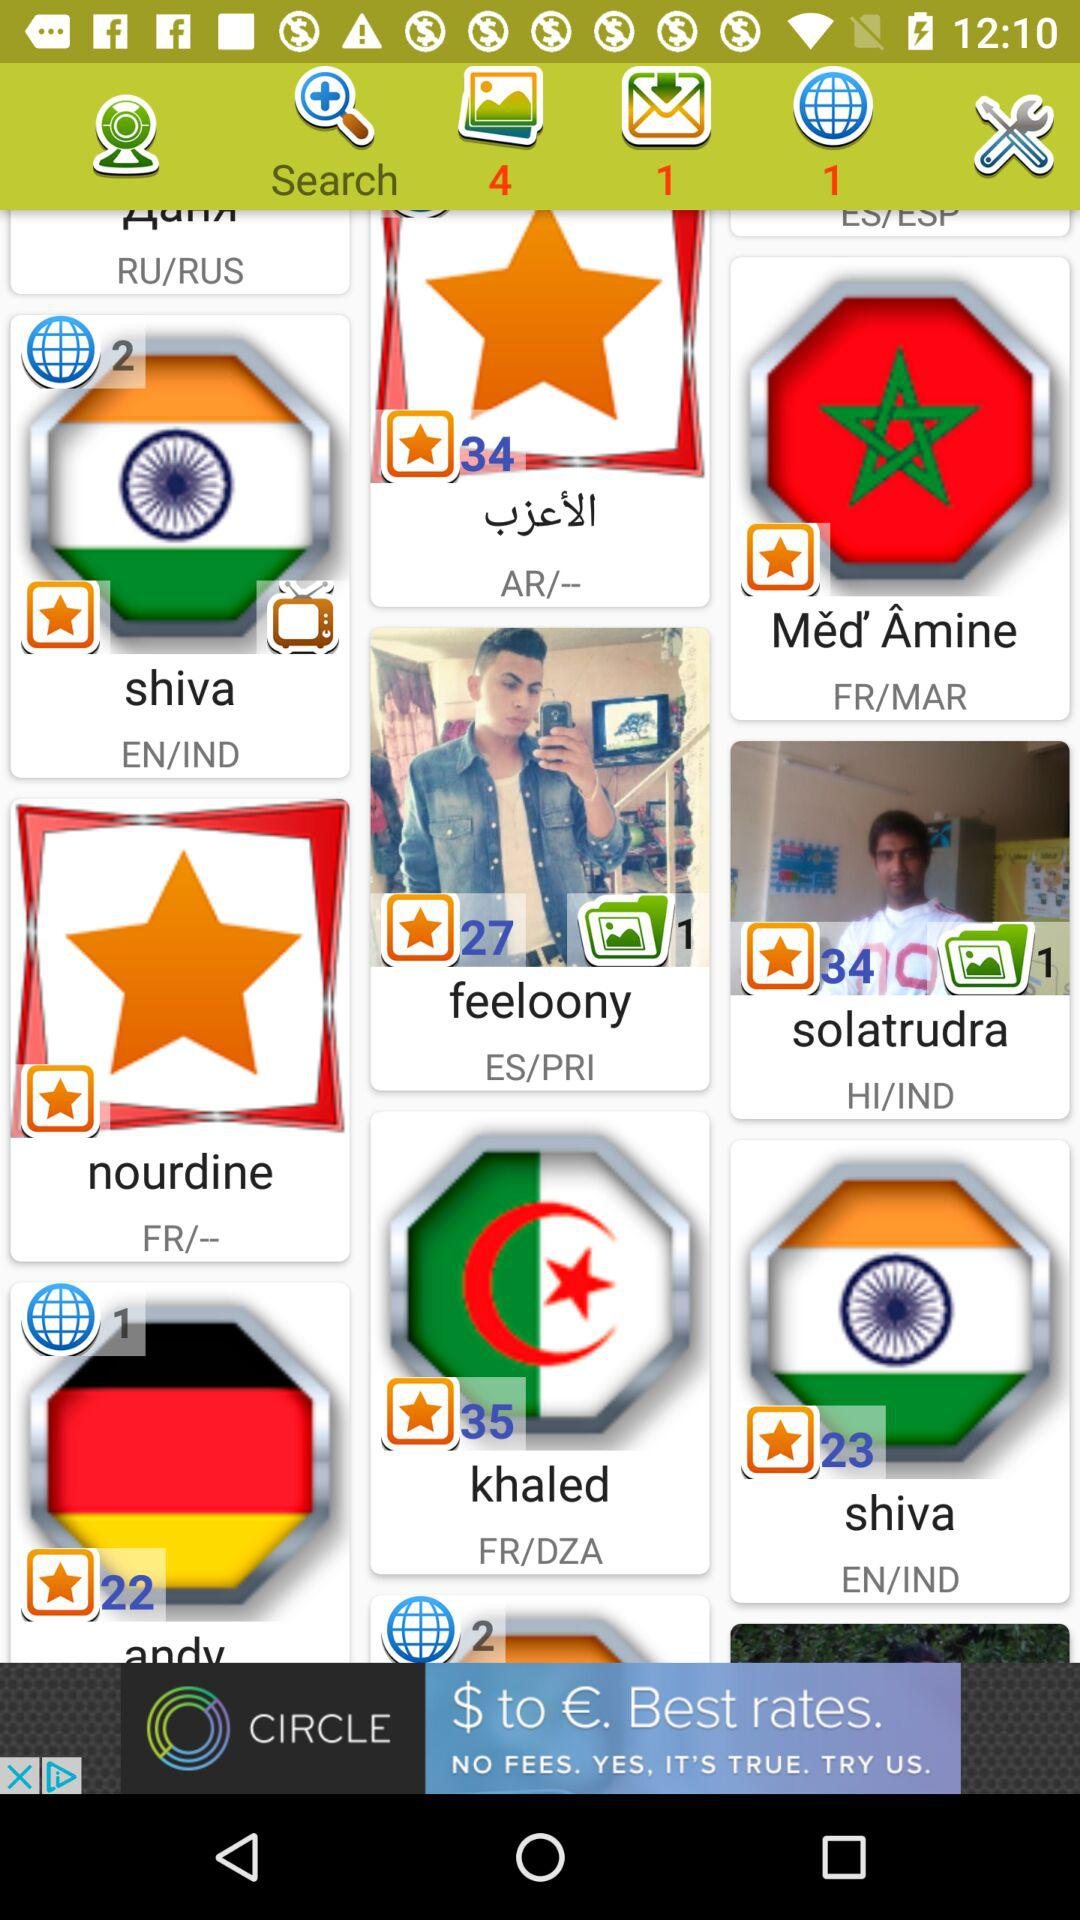How many emails have not yet been read? There is 1 email that has not yet been read. 